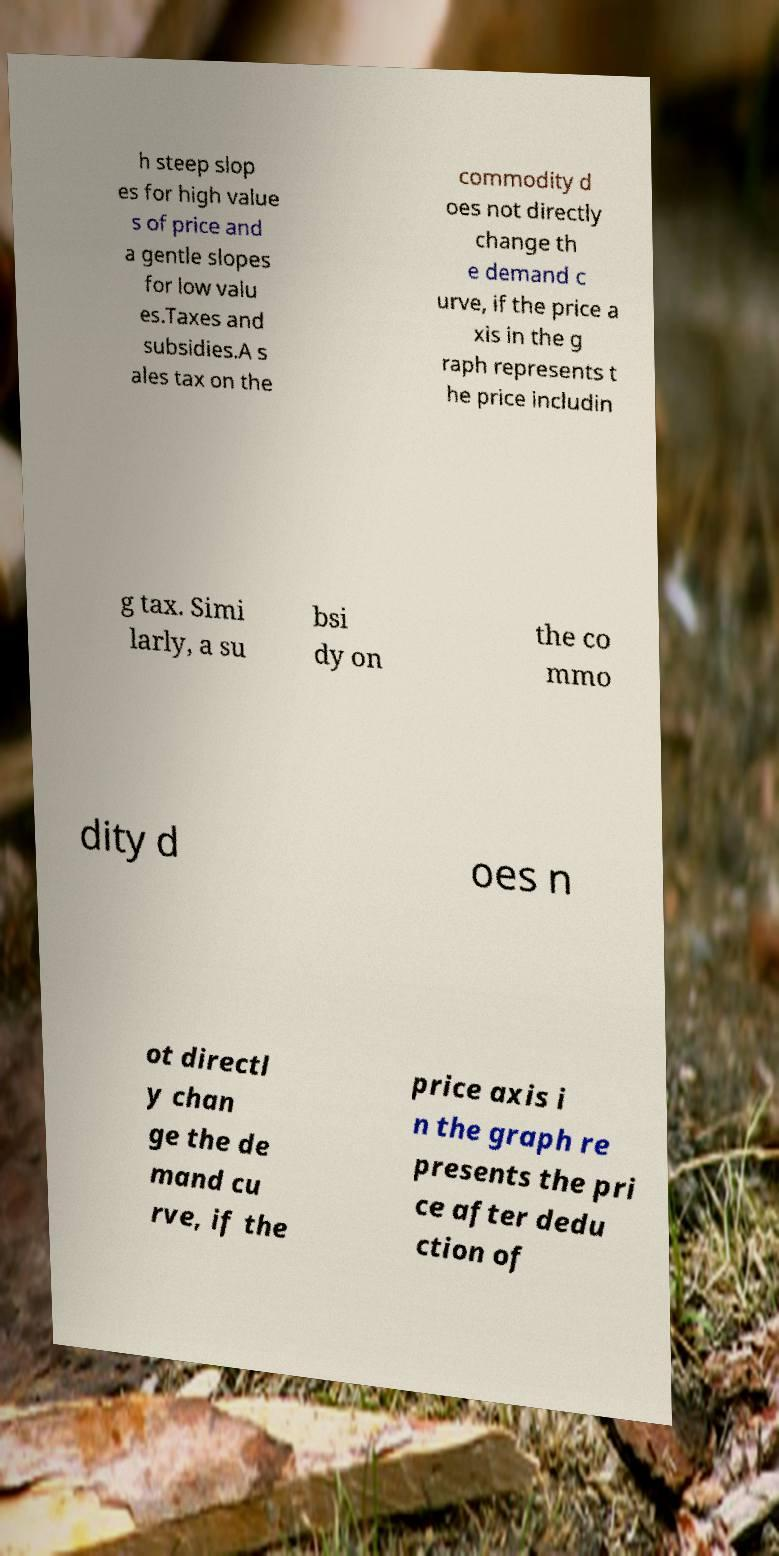For documentation purposes, I need the text within this image transcribed. Could you provide that? h steep slop es for high value s of price and a gentle slopes for low valu es.Taxes and subsidies.A s ales tax on the commodity d oes not directly change th e demand c urve, if the price a xis in the g raph represents t he price includin g tax. Simi larly, a su bsi dy on the co mmo dity d oes n ot directl y chan ge the de mand cu rve, if the price axis i n the graph re presents the pri ce after dedu ction of 